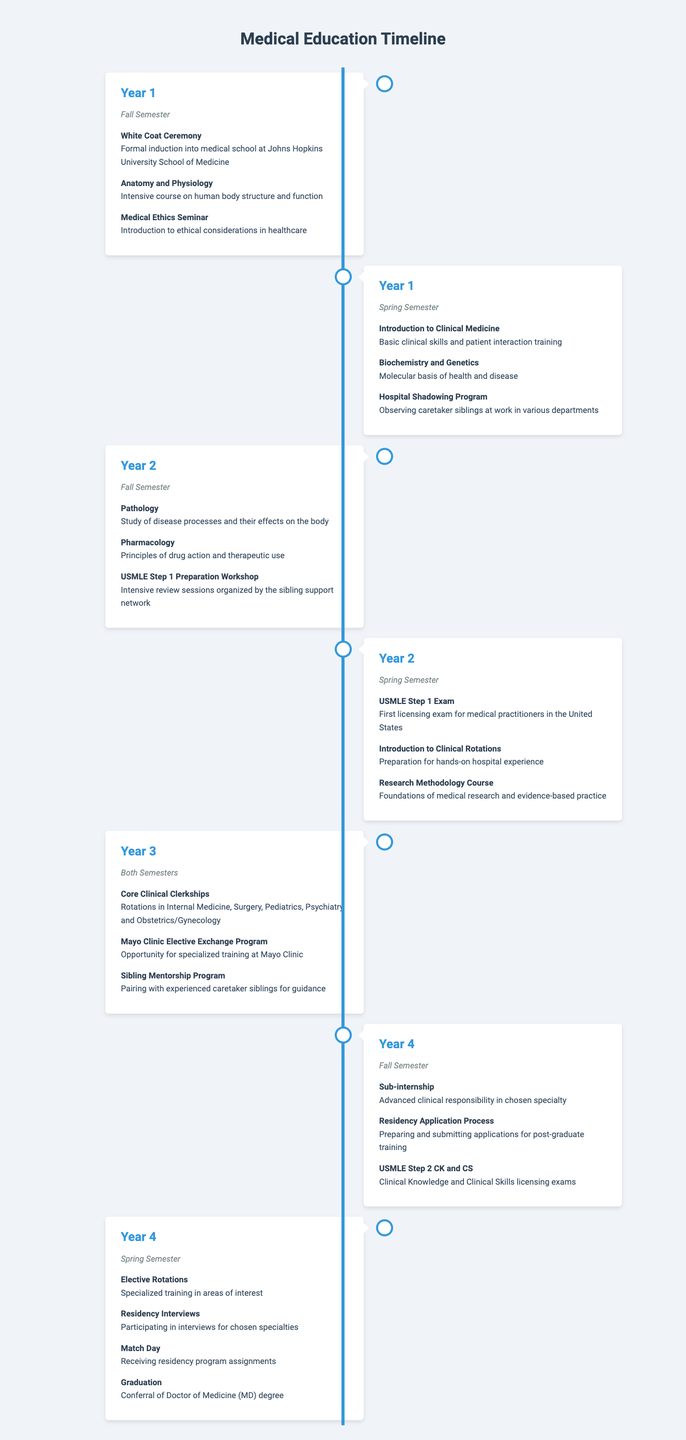What key event marks the beginning of the medical school journey? The table indicates that the "White Coat Ceremony" is the key event that marks the formal induction into medical school. It is listed in the Fall semester of Year 1.
Answer: White Coat Ceremony In which semester do students take the USMLE Step 1 Exam? The USMLE Step 1 Exam is scheduled for the Spring semester of Year 2, as noted in the respective row of the table.
Answer: Spring Semester of Year 2 How many events are listed for Year 4, Spring semester? There are four events listed for Year 4, Spring semester: "Elective Rotations," "Residency Interviews," "Match Day," and "Graduation." This can be verified by counting the events under that semester.
Answer: Four events Is the "Pathology" course offered in Year 1? The table clearly shows that the "Pathology" course is in Year 2, Fall semester, and not in Year 1. This indicates that the statement is false.
Answer: No Which year has the most significant transition in terms of practical experience? In Year 3, both semesters include "Core Clinical Clerkships," which involve practical hands-on experience in various medical fields. This transition from theoretical learning to practical application marks a significant shift in the curriculum, hence indicating Year 3 as having the most substantial practical experience focus.
Answer: Year 3 